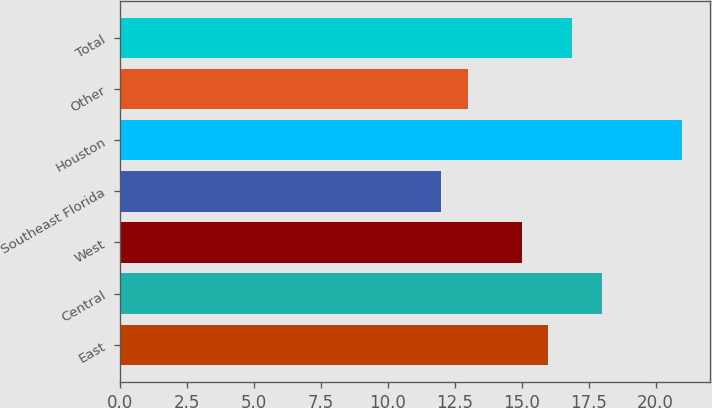<chart> <loc_0><loc_0><loc_500><loc_500><bar_chart><fcel>East<fcel>Central<fcel>West<fcel>Southeast Florida<fcel>Houston<fcel>Other<fcel>Total<nl><fcel>16<fcel>18<fcel>15<fcel>12<fcel>21<fcel>13<fcel>16.9<nl></chart> 